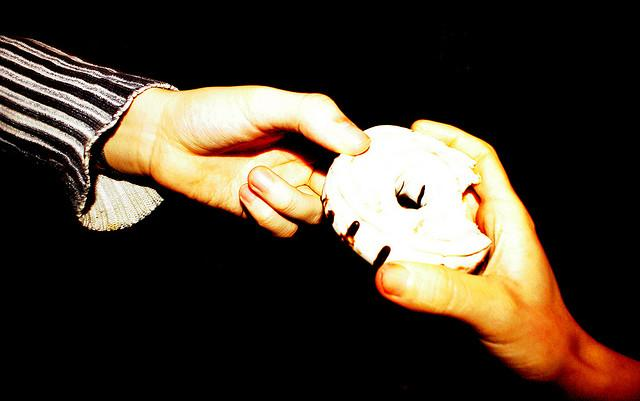Which person bit the donut? right 